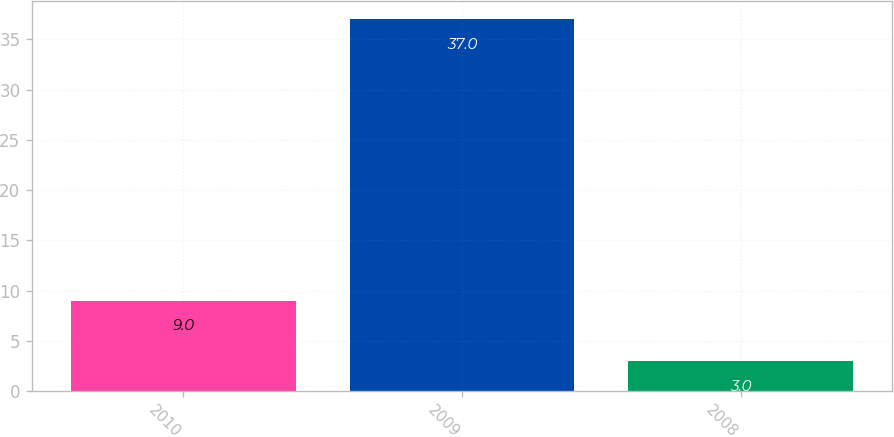<chart> <loc_0><loc_0><loc_500><loc_500><bar_chart><fcel>2010<fcel>2009<fcel>2008<nl><fcel>9<fcel>37<fcel>3<nl></chart> 